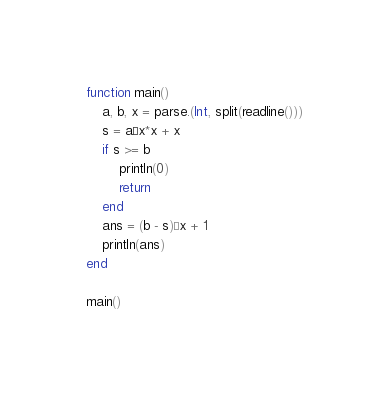Convert code to text. <code><loc_0><loc_0><loc_500><loc_500><_Julia_>function main()
    a, b, x = parse.(Int, split(readline()))
    s = a÷x*x + x
    if s >= b
        println(0)
        return
    end
    ans = (b - s)÷x + 1
    println(ans) 
end

main()</code> 